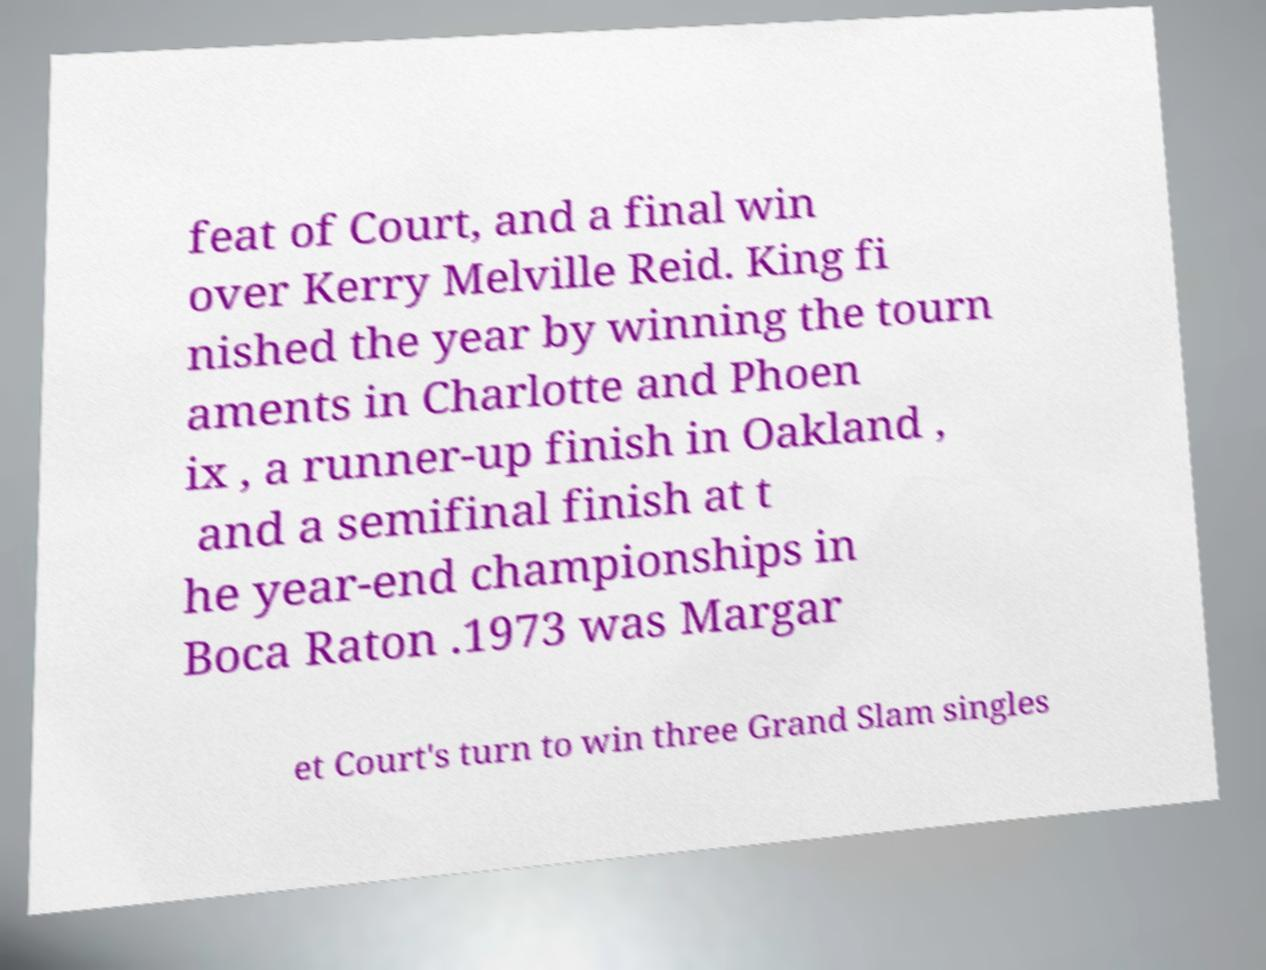Could you assist in decoding the text presented in this image and type it out clearly? feat of Court, and a final win over Kerry Melville Reid. King fi nished the year by winning the tourn aments in Charlotte and Phoen ix , a runner-up finish in Oakland , and a semifinal finish at t he year-end championships in Boca Raton .1973 was Margar et Court's turn to win three Grand Slam singles 